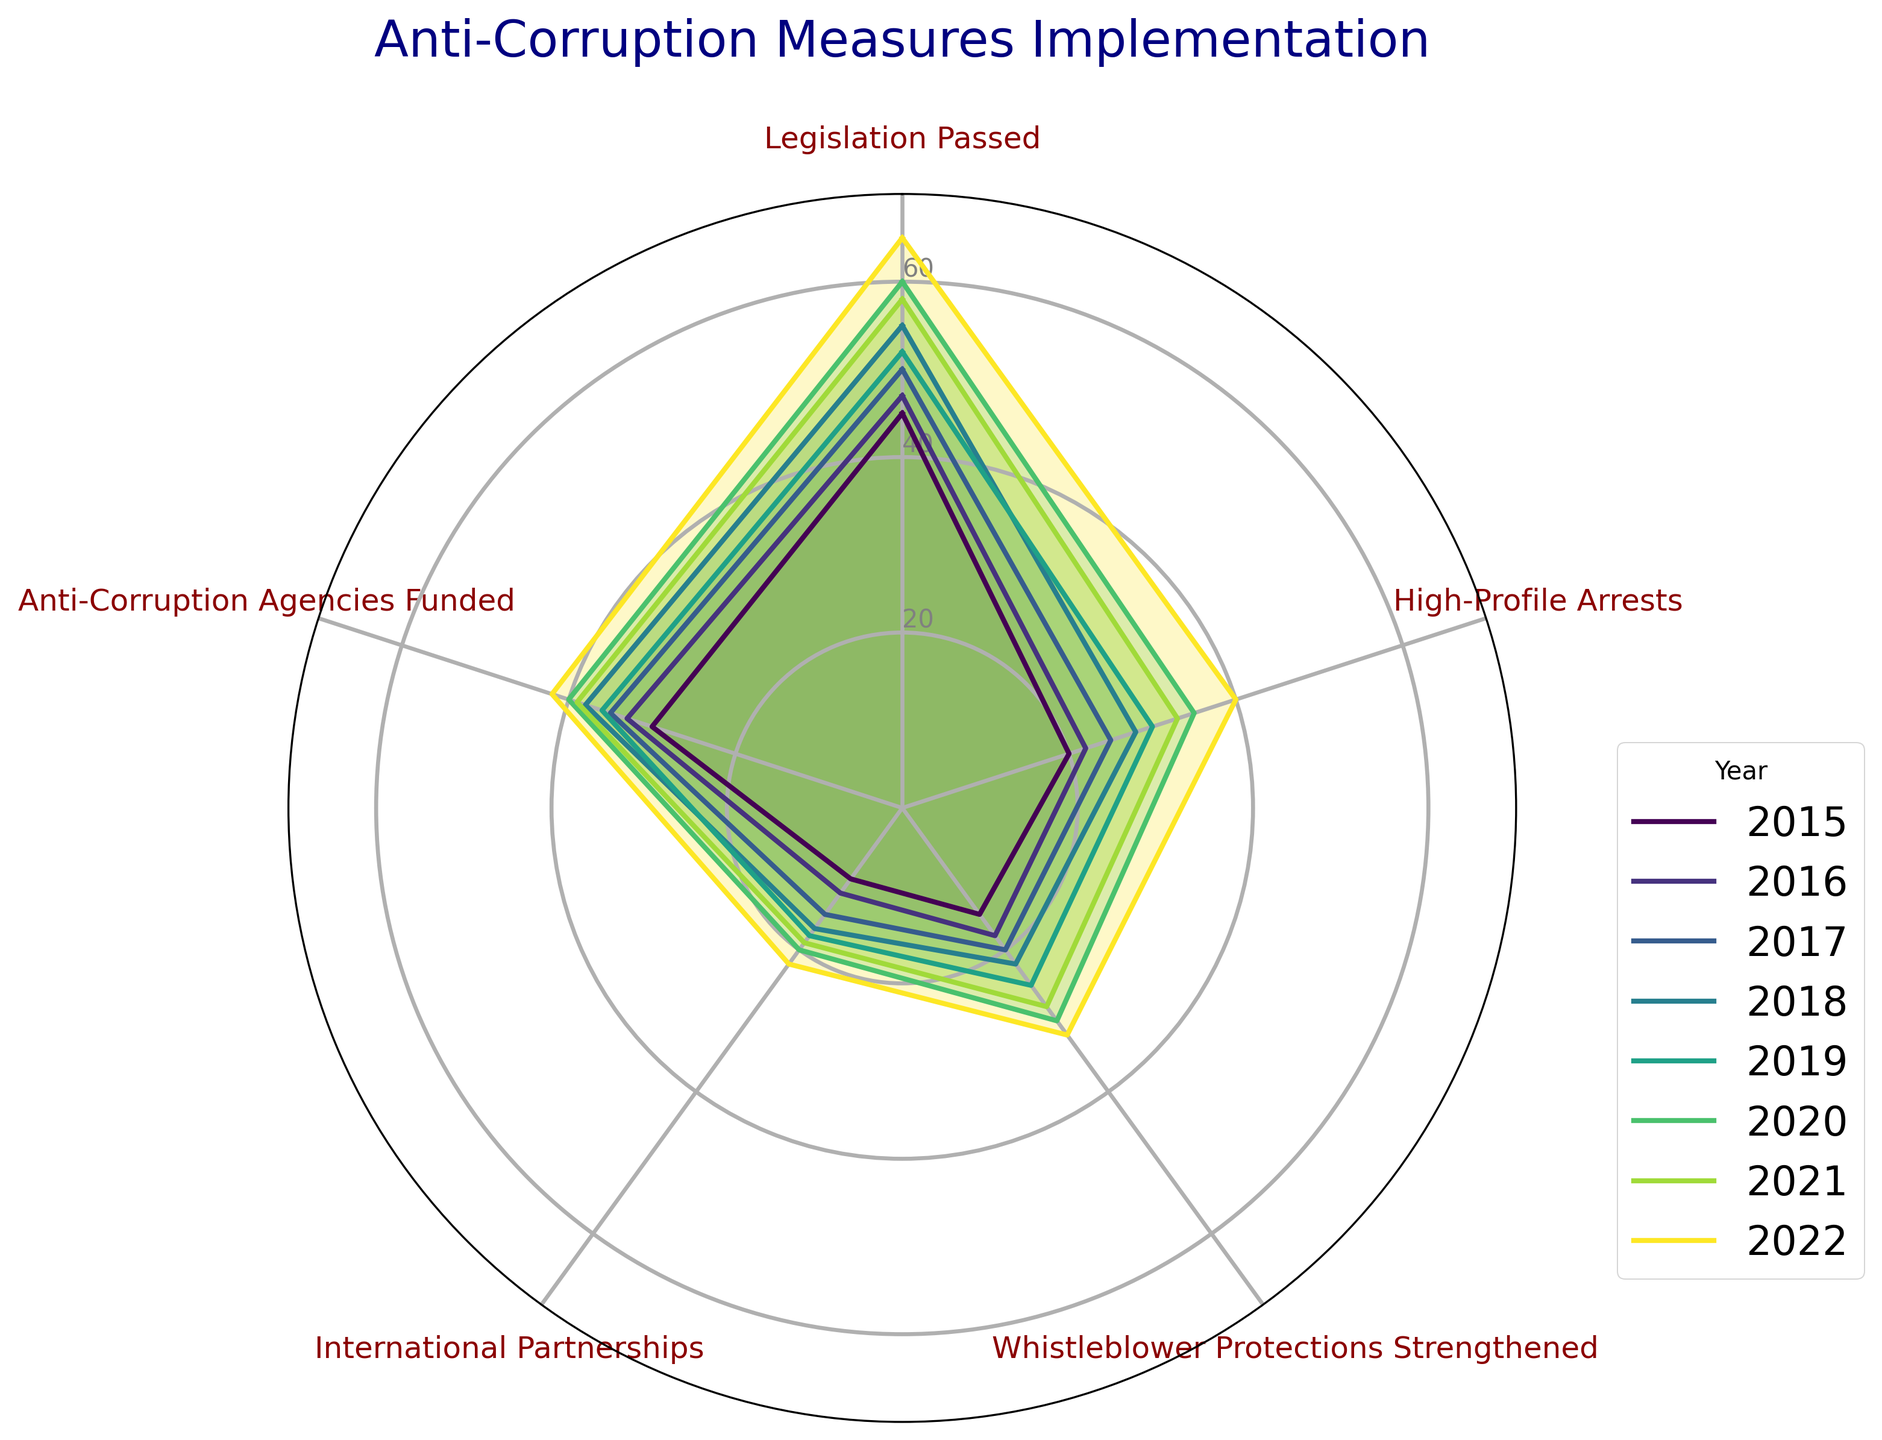What is the title of the radar chart? The title of the chart is written at the top and indicates what the chart is about. In this case, it is clearly labeled.
Answer: "Anti-Corruption Measures Implementation" How many anti-corruption measures are tracked in the radar chart? The radar chart shows different anti-corruption measures as categories around the chart. By counting them, we can see the number of measures tracked.
Answer: 5 Which year has the highest value for 'High-Profile Arrests'? Locate the lines representing each year and identify which line extends the furthest in the 'High-Profile Arrests' direction.
Answer: 2022 What is the sum of the 'Legislation Passed' values for 2015 and 2022? Find the 'Legislation Passed' values for 2015 and 2022 and add them together: 45 (2015) + 65 (2022) = 110.
Answer: 110 What is the average implementation frequency for 'Whistleblower Protections Strengthened' from 2015 to 2022? Add all the values from 2015 to 2022 and divide by the number of years: (15 + 18 + 20 + 22 + 25 + 30 + 28 + 32) / 8 = 190 / 8 = 23.75.
Answer: 23.75 Between 2018 and 2020, which anti-corruption measures increased? Compare the values for each measure between 2018 and 2020. If the 2020 value is greater than the 2018 value, it indicates an increase. All measures had increased: 'Legislation Passed' (55 to 60), 'High-Profile Arrests' (28 to 35), 'Whistleblower Protections Strengthened' (22 to 30), 'International Partnerships' (17 to 20), and 'Anti-Corruption Agencies Funded' (38 to 40).
Answer: All measures What are the two anti-corruption measures with the greatest increase in frequency from 2015 to 2022? Calculate the difference between the values for each measure between 2015 and 2022 and identify the two largest increases: 'Legislation Passed' (65 - 45 = 20) and 'High-Profile Arrests' (40 - 20 = 20).
Answer: 'Legislation Passed' and 'High-Profile Arrests' Did the frequency of 'International Partnerships' ever decrease from one year to the next between 2015 and 2022? Observe the values year by year. If a later year has a lower value than the preceding year, it indicates a decrease. Here, we see 10 (2015), 12 (2016), 15 (2017), 17 (2018), 18 (2019), 20 (2020), 19 (2021), and 22 (2022). There is a decrease from 2020 to 2021.
Answer: Yes How does the 2021 frequency of 'Anti-Corruption Agencies Funded' compare to the 2019 frequency? Compare the values for 2021 and 2019. In 2021, the value is 39 and in 2019 it is 36.
Answer: 2021 is greater than 2019 